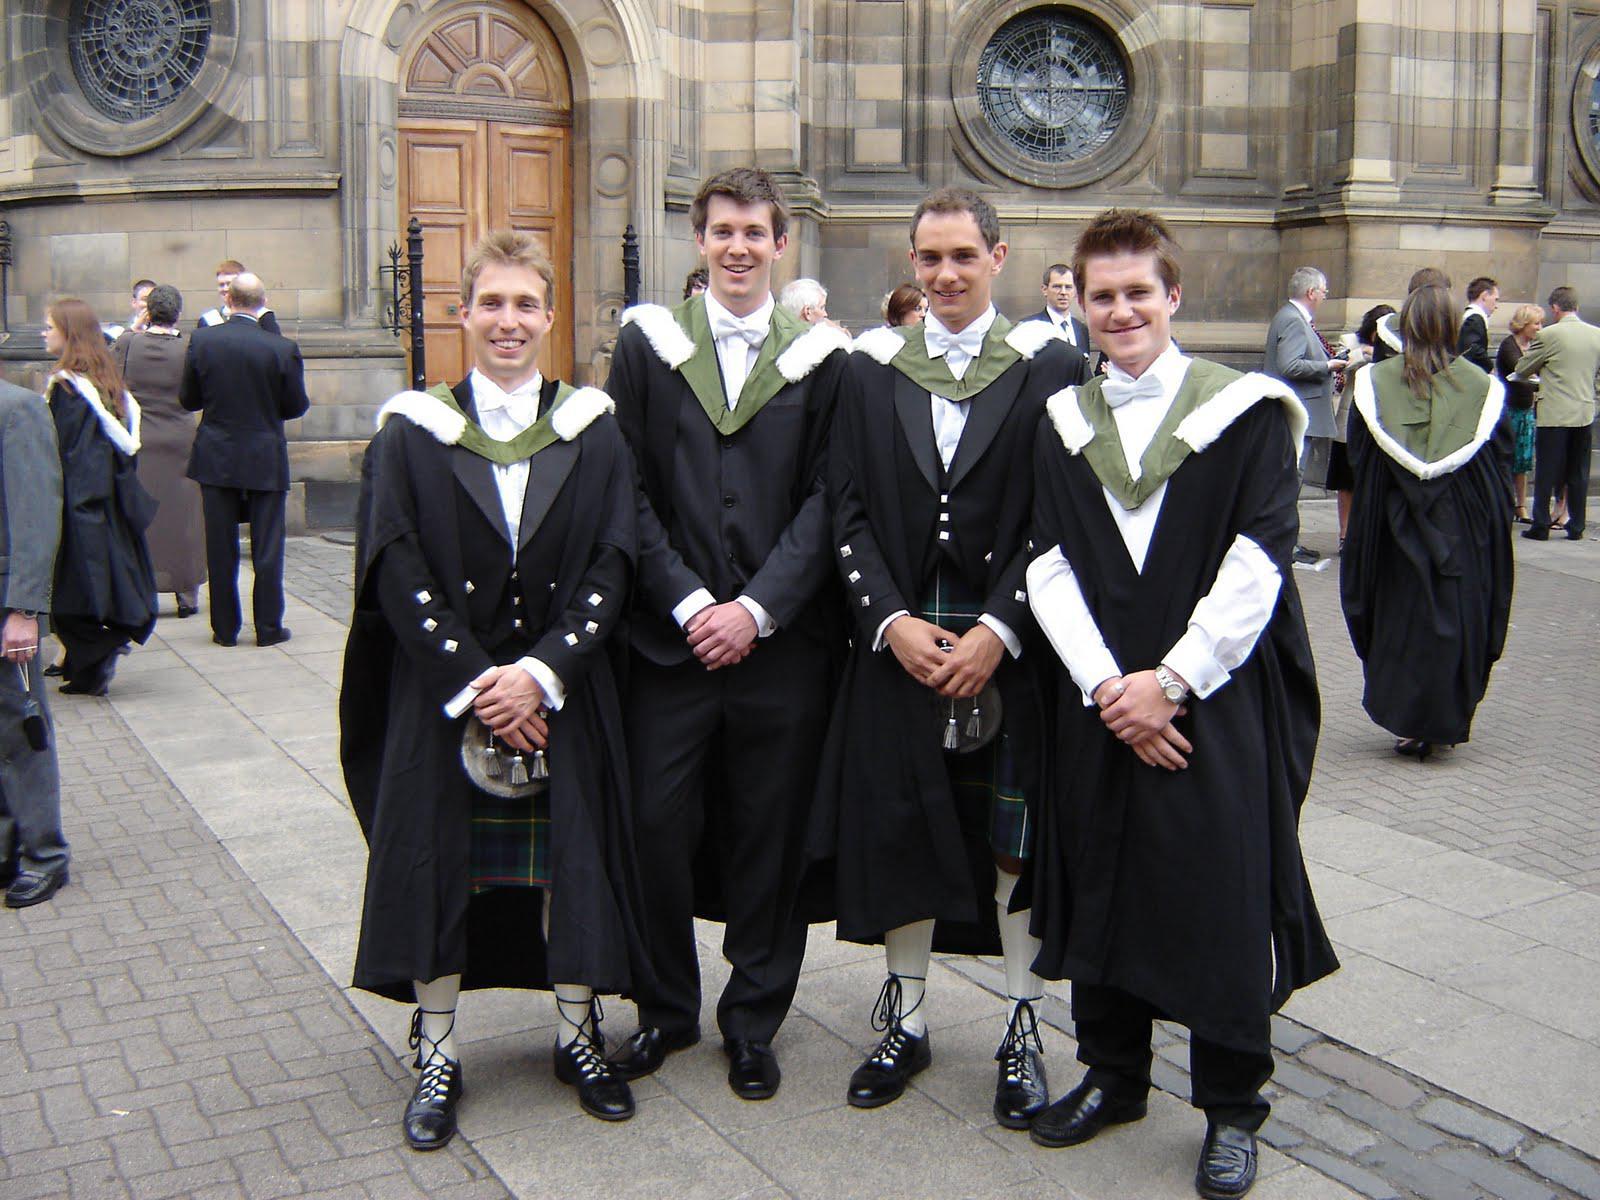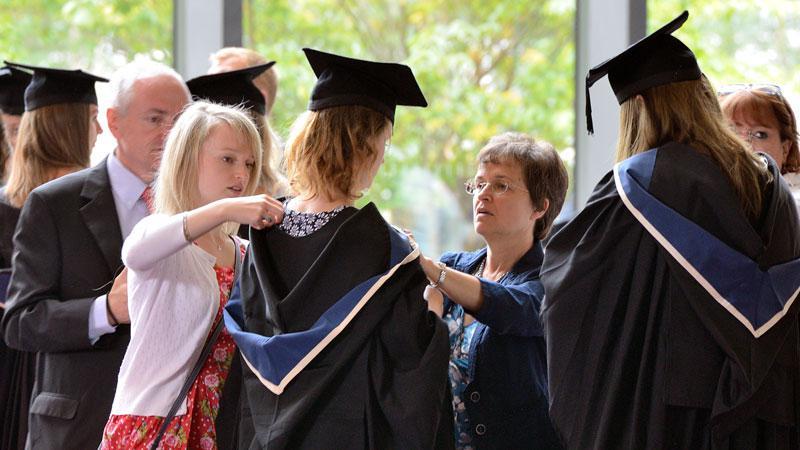The first image is the image on the left, the second image is the image on the right. Analyze the images presented: Is the assertion "The left image shows a group of four people." valid? Answer yes or no. Yes. 